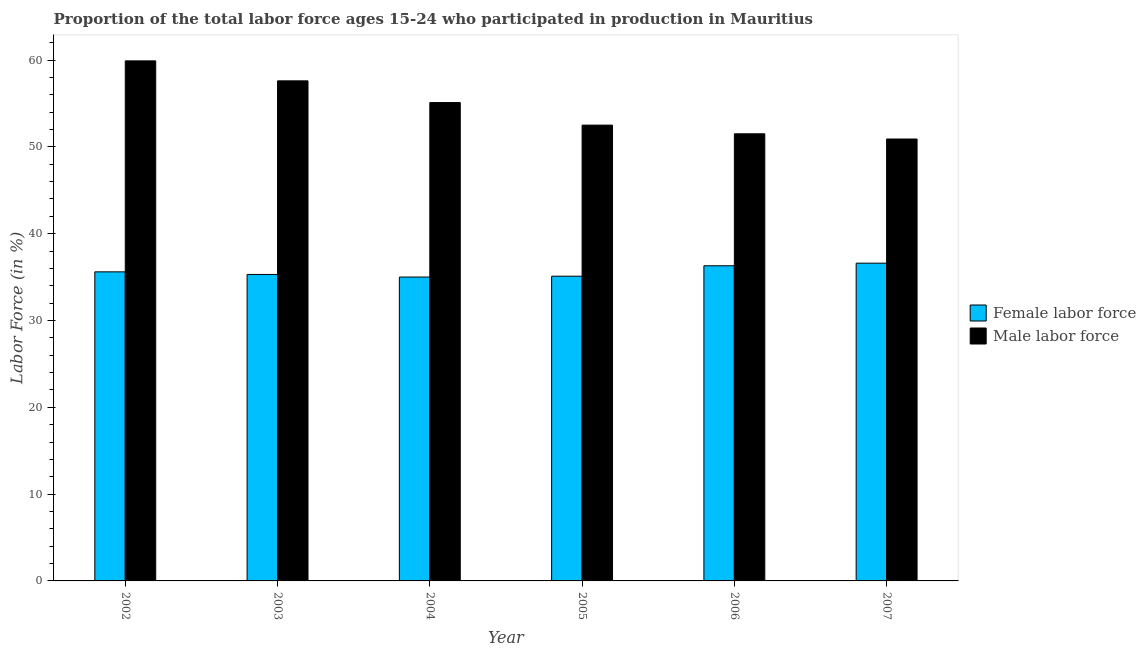How many groups of bars are there?
Your response must be concise. 6. Are the number of bars on each tick of the X-axis equal?
Keep it short and to the point. Yes. How many bars are there on the 6th tick from the left?
Make the answer very short. 2. How many bars are there on the 4th tick from the right?
Your answer should be very brief. 2. In how many cases, is the number of bars for a given year not equal to the number of legend labels?
Offer a terse response. 0. What is the percentage of female labor force in 2003?
Provide a short and direct response. 35.3. Across all years, what is the maximum percentage of female labor force?
Your answer should be compact. 36.6. Across all years, what is the minimum percentage of male labour force?
Keep it short and to the point. 50.9. In which year was the percentage of female labor force maximum?
Offer a terse response. 2007. What is the total percentage of female labor force in the graph?
Make the answer very short. 213.9. What is the difference between the percentage of female labor force in 2005 and that in 2006?
Provide a short and direct response. -1.2. What is the difference between the percentage of female labor force in 2006 and the percentage of male labour force in 2007?
Keep it short and to the point. -0.3. What is the average percentage of female labor force per year?
Give a very brief answer. 35.65. In how many years, is the percentage of female labor force greater than 58 %?
Make the answer very short. 0. What is the ratio of the percentage of male labour force in 2003 to that in 2004?
Provide a succinct answer. 1.05. Is the percentage of female labor force in 2002 less than that in 2007?
Give a very brief answer. Yes. What is the difference between the highest and the second highest percentage of male labour force?
Give a very brief answer. 2.3. What is the difference between the highest and the lowest percentage of female labor force?
Offer a very short reply. 1.6. Is the sum of the percentage of female labor force in 2006 and 2007 greater than the maximum percentage of male labour force across all years?
Your answer should be very brief. Yes. What does the 2nd bar from the left in 2007 represents?
Ensure brevity in your answer.  Male labor force. What does the 1st bar from the right in 2006 represents?
Keep it short and to the point. Male labor force. How many bars are there?
Your answer should be very brief. 12. Does the graph contain any zero values?
Your answer should be very brief. No. Does the graph contain grids?
Make the answer very short. No. How are the legend labels stacked?
Make the answer very short. Vertical. What is the title of the graph?
Your answer should be very brief. Proportion of the total labor force ages 15-24 who participated in production in Mauritius. Does "Not attending school" appear as one of the legend labels in the graph?
Keep it short and to the point. No. What is the label or title of the X-axis?
Offer a terse response. Year. What is the Labor Force (in %) of Female labor force in 2002?
Provide a succinct answer. 35.6. What is the Labor Force (in %) in Male labor force in 2002?
Your answer should be very brief. 59.9. What is the Labor Force (in %) of Female labor force in 2003?
Your response must be concise. 35.3. What is the Labor Force (in %) in Male labor force in 2003?
Your answer should be compact. 57.6. What is the Labor Force (in %) in Female labor force in 2004?
Give a very brief answer. 35. What is the Labor Force (in %) of Male labor force in 2004?
Keep it short and to the point. 55.1. What is the Labor Force (in %) of Female labor force in 2005?
Your answer should be compact. 35.1. What is the Labor Force (in %) in Male labor force in 2005?
Provide a short and direct response. 52.5. What is the Labor Force (in %) of Female labor force in 2006?
Give a very brief answer. 36.3. What is the Labor Force (in %) of Male labor force in 2006?
Ensure brevity in your answer.  51.5. What is the Labor Force (in %) of Female labor force in 2007?
Your answer should be compact. 36.6. What is the Labor Force (in %) in Male labor force in 2007?
Your response must be concise. 50.9. Across all years, what is the maximum Labor Force (in %) of Female labor force?
Your response must be concise. 36.6. Across all years, what is the maximum Labor Force (in %) of Male labor force?
Offer a very short reply. 59.9. Across all years, what is the minimum Labor Force (in %) in Male labor force?
Provide a short and direct response. 50.9. What is the total Labor Force (in %) in Female labor force in the graph?
Provide a succinct answer. 213.9. What is the total Labor Force (in %) of Male labor force in the graph?
Your answer should be compact. 327.5. What is the difference between the Labor Force (in %) of Male labor force in 2002 and that in 2003?
Offer a terse response. 2.3. What is the difference between the Labor Force (in %) in Female labor force in 2002 and that in 2005?
Provide a short and direct response. 0.5. What is the difference between the Labor Force (in %) in Male labor force in 2002 and that in 2005?
Offer a very short reply. 7.4. What is the difference between the Labor Force (in %) of Female labor force in 2003 and that in 2004?
Your answer should be compact. 0.3. What is the difference between the Labor Force (in %) in Male labor force in 2003 and that in 2004?
Your response must be concise. 2.5. What is the difference between the Labor Force (in %) in Female labor force in 2003 and that in 2005?
Offer a terse response. 0.2. What is the difference between the Labor Force (in %) in Male labor force in 2003 and that in 2005?
Provide a short and direct response. 5.1. What is the difference between the Labor Force (in %) in Male labor force in 2003 and that in 2007?
Give a very brief answer. 6.7. What is the difference between the Labor Force (in %) in Male labor force in 2004 and that in 2005?
Your response must be concise. 2.6. What is the difference between the Labor Force (in %) of Male labor force in 2004 and that in 2007?
Your answer should be very brief. 4.2. What is the difference between the Labor Force (in %) of Female labor force in 2005 and that in 2006?
Your response must be concise. -1.2. What is the difference between the Labor Force (in %) in Male labor force in 2005 and that in 2006?
Make the answer very short. 1. What is the difference between the Labor Force (in %) of Female labor force in 2006 and that in 2007?
Make the answer very short. -0.3. What is the difference between the Labor Force (in %) of Male labor force in 2006 and that in 2007?
Provide a short and direct response. 0.6. What is the difference between the Labor Force (in %) in Female labor force in 2002 and the Labor Force (in %) in Male labor force in 2003?
Keep it short and to the point. -22. What is the difference between the Labor Force (in %) of Female labor force in 2002 and the Labor Force (in %) of Male labor force in 2004?
Ensure brevity in your answer.  -19.5. What is the difference between the Labor Force (in %) of Female labor force in 2002 and the Labor Force (in %) of Male labor force in 2005?
Provide a short and direct response. -16.9. What is the difference between the Labor Force (in %) in Female labor force in 2002 and the Labor Force (in %) in Male labor force in 2006?
Make the answer very short. -15.9. What is the difference between the Labor Force (in %) in Female labor force in 2002 and the Labor Force (in %) in Male labor force in 2007?
Give a very brief answer. -15.3. What is the difference between the Labor Force (in %) in Female labor force in 2003 and the Labor Force (in %) in Male labor force in 2004?
Provide a succinct answer. -19.8. What is the difference between the Labor Force (in %) of Female labor force in 2003 and the Labor Force (in %) of Male labor force in 2005?
Your answer should be very brief. -17.2. What is the difference between the Labor Force (in %) of Female labor force in 2003 and the Labor Force (in %) of Male labor force in 2006?
Your response must be concise. -16.2. What is the difference between the Labor Force (in %) in Female labor force in 2003 and the Labor Force (in %) in Male labor force in 2007?
Offer a very short reply. -15.6. What is the difference between the Labor Force (in %) of Female labor force in 2004 and the Labor Force (in %) of Male labor force in 2005?
Give a very brief answer. -17.5. What is the difference between the Labor Force (in %) in Female labor force in 2004 and the Labor Force (in %) in Male labor force in 2006?
Your answer should be very brief. -16.5. What is the difference between the Labor Force (in %) in Female labor force in 2004 and the Labor Force (in %) in Male labor force in 2007?
Offer a very short reply. -15.9. What is the difference between the Labor Force (in %) in Female labor force in 2005 and the Labor Force (in %) in Male labor force in 2006?
Make the answer very short. -16.4. What is the difference between the Labor Force (in %) of Female labor force in 2005 and the Labor Force (in %) of Male labor force in 2007?
Offer a very short reply. -15.8. What is the difference between the Labor Force (in %) in Female labor force in 2006 and the Labor Force (in %) in Male labor force in 2007?
Give a very brief answer. -14.6. What is the average Labor Force (in %) in Female labor force per year?
Your answer should be very brief. 35.65. What is the average Labor Force (in %) of Male labor force per year?
Give a very brief answer. 54.58. In the year 2002, what is the difference between the Labor Force (in %) of Female labor force and Labor Force (in %) of Male labor force?
Provide a short and direct response. -24.3. In the year 2003, what is the difference between the Labor Force (in %) in Female labor force and Labor Force (in %) in Male labor force?
Ensure brevity in your answer.  -22.3. In the year 2004, what is the difference between the Labor Force (in %) in Female labor force and Labor Force (in %) in Male labor force?
Provide a succinct answer. -20.1. In the year 2005, what is the difference between the Labor Force (in %) of Female labor force and Labor Force (in %) of Male labor force?
Your answer should be compact. -17.4. In the year 2006, what is the difference between the Labor Force (in %) in Female labor force and Labor Force (in %) in Male labor force?
Your answer should be very brief. -15.2. In the year 2007, what is the difference between the Labor Force (in %) of Female labor force and Labor Force (in %) of Male labor force?
Provide a short and direct response. -14.3. What is the ratio of the Labor Force (in %) of Female labor force in 2002 to that in 2003?
Your answer should be very brief. 1.01. What is the ratio of the Labor Force (in %) of Male labor force in 2002 to that in 2003?
Your answer should be very brief. 1.04. What is the ratio of the Labor Force (in %) of Female labor force in 2002 to that in 2004?
Ensure brevity in your answer.  1.02. What is the ratio of the Labor Force (in %) in Male labor force in 2002 to that in 2004?
Ensure brevity in your answer.  1.09. What is the ratio of the Labor Force (in %) in Female labor force in 2002 to that in 2005?
Your answer should be compact. 1.01. What is the ratio of the Labor Force (in %) of Male labor force in 2002 to that in 2005?
Your response must be concise. 1.14. What is the ratio of the Labor Force (in %) in Female labor force in 2002 to that in 2006?
Make the answer very short. 0.98. What is the ratio of the Labor Force (in %) of Male labor force in 2002 to that in 2006?
Give a very brief answer. 1.16. What is the ratio of the Labor Force (in %) in Female labor force in 2002 to that in 2007?
Provide a short and direct response. 0.97. What is the ratio of the Labor Force (in %) of Male labor force in 2002 to that in 2007?
Provide a succinct answer. 1.18. What is the ratio of the Labor Force (in %) in Female labor force in 2003 to that in 2004?
Offer a very short reply. 1.01. What is the ratio of the Labor Force (in %) in Male labor force in 2003 to that in 2004?
Give a very brief answer. 1.05. What is the ratio of the Labor Force (in %) in Female labor force in 2003 to that in 2005?
Keep it short and to the point. 1.01. What is the ratio of the Labor Force (in %) in Male labor force in 2003 to that in 2005?
Your answer should be compact. 1.1. What is the ratio of the Labor Force (in %) of Female labor force in 2003 to that in 2006?
Offer a very short reply. 0.97. What is the ratio of the Labor Force (in %) in Male labor force in 2003 to that in 2006?
Make the answer very short. 1.12. What is the ratio of the Labor Force (in %) in Female labor force in 2003 to that in 2007?
Offer a very short reply. 0.96. What is the ratio of the Labor Force (in %) in Male labor force in 2003 to that in 2007?
Your response must be concise. 1.13. What is the ratio of the Labor Force (in %) of Male labor force in 2004 to that in 2005?
Provide a short and direct response. 1.05. What is the ratio of the Labor Force (in %) in Female labor force in 2004 to that in 2006?
Give a very brief answer. 0.96. What is the ratio of the Labor Force (in %) in Male labor force in 2004 to that in 2006?
Offer a terse response. 1.07. What is the ratio of the Labor Force (in %) in Female labor force in 2004 to that in 2007?
Offer a terse response. 0.96. What is the ratio of the Labor Force (in %) of Male labor force in 2004 to that in 2007?
Offer a terse response. 1.08. What is the ratio of the Labor Force (in %) in Female labor force in 2005 to that in 2006?
Provide a short and direct response. 0.97. What is the ratio of the Labor Force (in %) of Male labor force in 2005 to that in 2006?
Offer a very short reply. 1.02. What is the ratio of the Labor Force (in %) of Male labor force in 2005 to that in 2007?
Make the answer very short. 1.03. What is the ratio of the Labor Force (in %) in Male labor force in 2006 to that in 2007?
Your answer should be very brief. 1.01. What is the difference between the highest and the second highest Labor Force (in %) in Male labor force?
Your response must be concise. 2.3. 